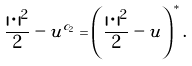<formula> <loc_0><loc_0><loc_500><loc_500>\frac { | \, \cdot \, | ^ { 2 } } 2 - u ^ { c _ { 2 } } = \left ( \frac { | \, \cdot \, | ^ { 2 } } 2 - u \right ) ^ { * } .</formula> 